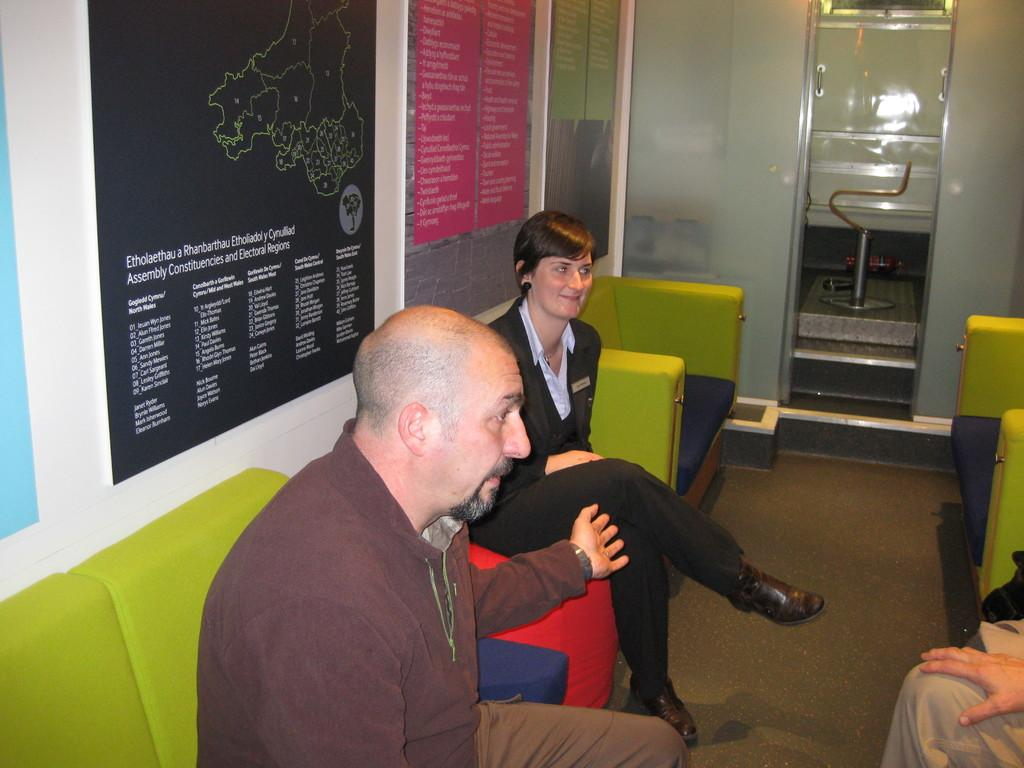<image>
Create a compact narrative representing the image presented. people chatting on lime green couches near signs for Etholaethau a Rhanbartha 